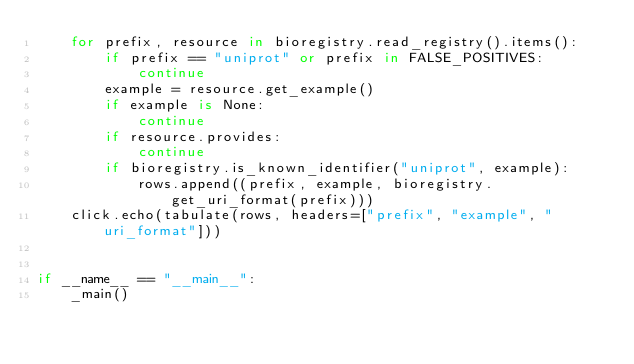<code> <loc_0><loc_0><loc_500><loc_500><_Python_>    for prefix, resource in bioregistry.read_registry().items():
        if prefix == "uniprot" or prefix in FALSE_POSITIVES:
            continue
        example = resource.get_example()
        if example is None:
            continue
        if resource.provides:
            continue
        if bioregistry.is_known_identifier("uniprot", example):
            rows.append((prefix, example, bioregistry.get_uri_format(prefix)))
    click.echo(tabulate(rows, headers=["prefix", "example", "uri_format"]))


if __name__ == "__main__":
    _main()
</code> 